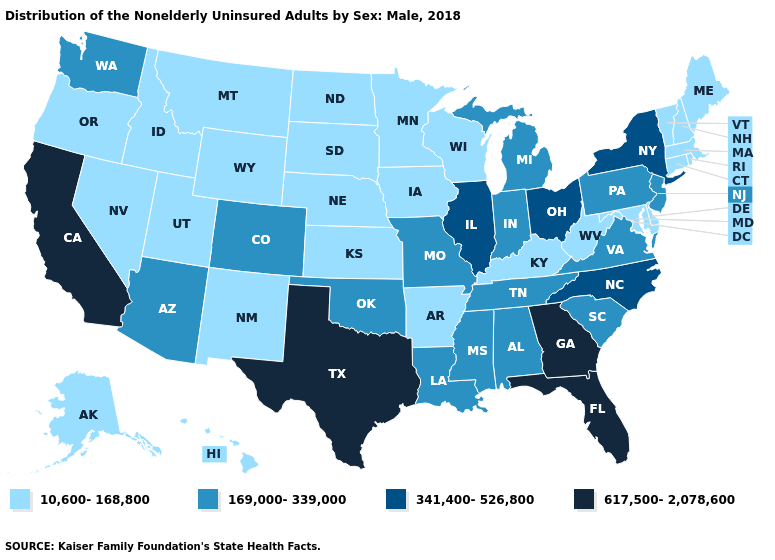Does Missouri have a higher value than Massachusetts?
Answer briefly. Yes. What is the lowest value in the South?
Write a very short answer. 10,600-168,800. Does Delaware have the lowest value in the South?
Keep it brief. Yes. Does Ohio have the lowest value in the MidWest?
Be succinct. No. What is the lowest value in the MidWest?
Quick response, please. 10,600-168,800. Name the states that have a value in the range 169,000-339,000?
Write a very short answer. Alabama, Arizona, Colorado, Indiana, Louisiana, Michigan, Mississippi, Missouri, New Jersey, Oklahoma, Pennsylvania, South Carolina, Tennessee, Virginia, Washington. Does Delaware have the lowest value in the South?
Short answer required. Yes. What is the highest value in states that border Tennessee?
Write a very short answer. 617,500-2,078,600. What is the highest value in the MidWest ?
Write a very short answer. 341,400-526,800. Does Montana have the same value as California?
Answer briefly. No. What is the value of Virginia?
Keep it brief. 169,000-339,000. Does the first symbol in the legend represent the smallest category?
Short answer required. Yes. What is the highest value in the USA?
Be succinct. 617,500-2,078,600. Does Mississippi have the same value as Georgia?
Keep it brief. No. What is the value of Colorado?
Be succinct. 169,000-339,000. 